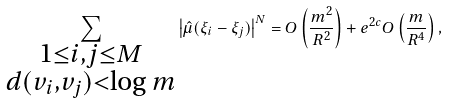<formula> <loc_0><loc_0><loc_500><loc_500>\sum _ { \substack { 1 \leq i , j \leq M \\ d ( v _ { i } , v _ { j } ) < \log m } } \left | \hat { \mu } ( \xi _ { i } - \xi _ { j } ) \right | ^ { N } = O \left ( \frac { m ^ { 2 } } { R ^ { 2 } } \right ) + e ^ { 2 c } O \left ( \frac { m } { R ^ { 4 } } \right ) ,</formula> 